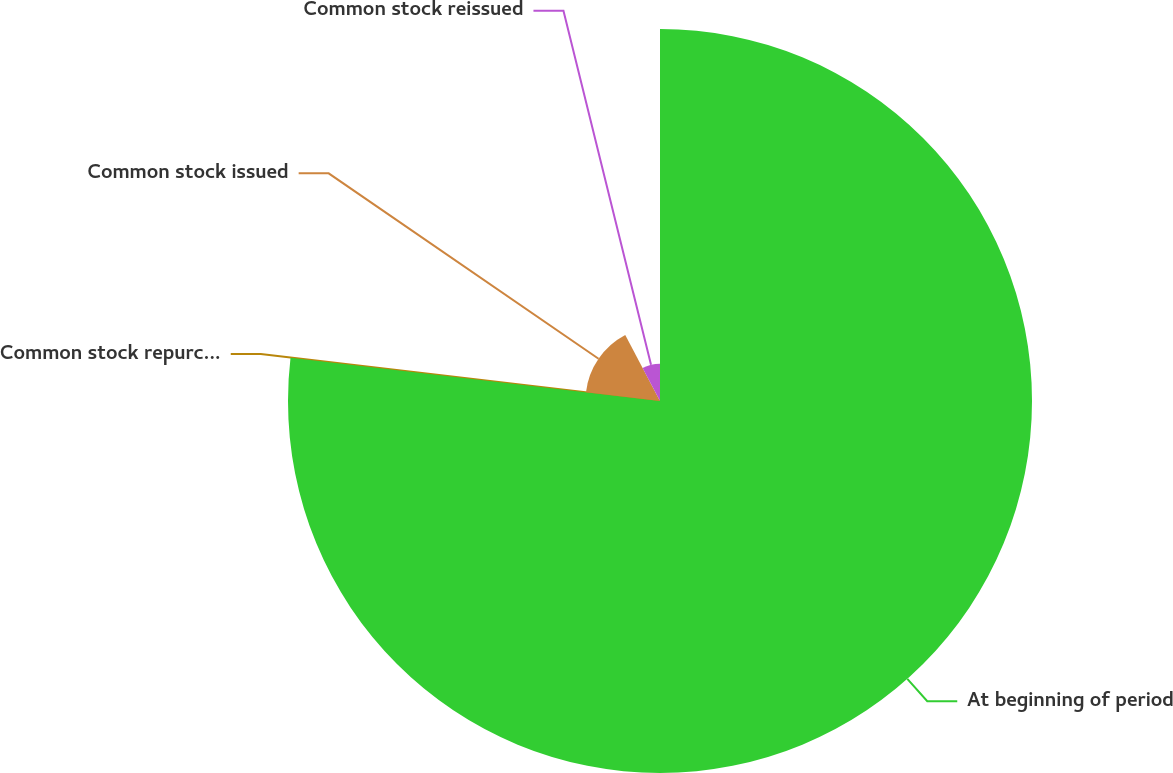Convert chart to OTSL. <chart><loc_0><loc_0><loc_500><loc_500><pie_chart><fcel>At beginning of period<fcel>Common stock repurchased<fcel>Common stock issued<fcel>Common stock reissued<nl><fcel>76.85%<fcel>0.03%<fcel>15.4%<fcel>7.72%<nl></chart> 